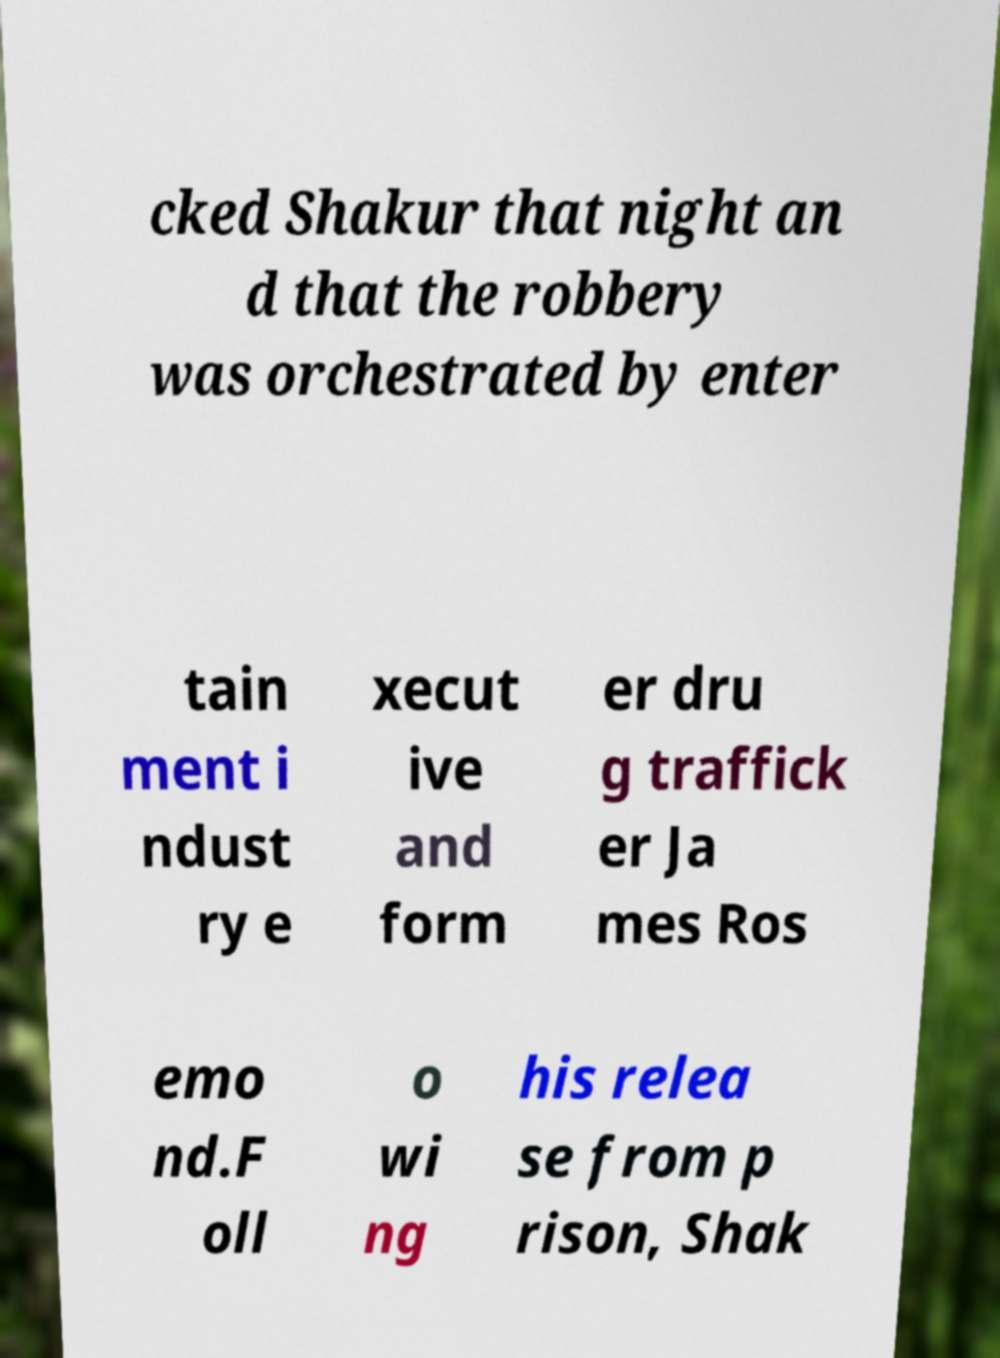Could you assist in decoding the text presented in this image and type it out clearly? cked Shakur that night an d that the robbery was orchestrated by enter tain ment i ndust ry e xecut ive and form er dru g traffick er Ja mes Ros emo nd.F oll o wi ng his relea se from p rison, Shak 